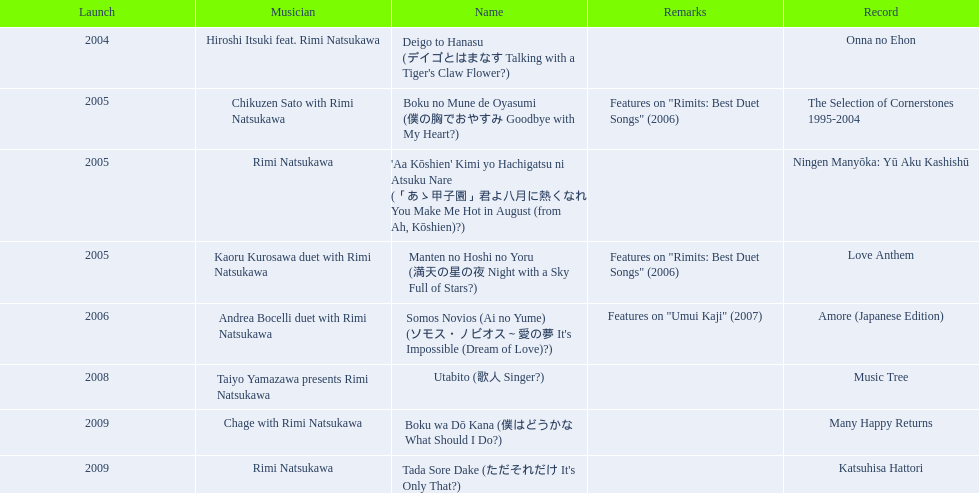What are the notes for sky full of stars? Features on "Rimits: Best Duet Songs" (2006). What other song features this same note? Boku no Mune de Oyasumi (僕の胸でおやすみ Goodbye with My Heart?). 